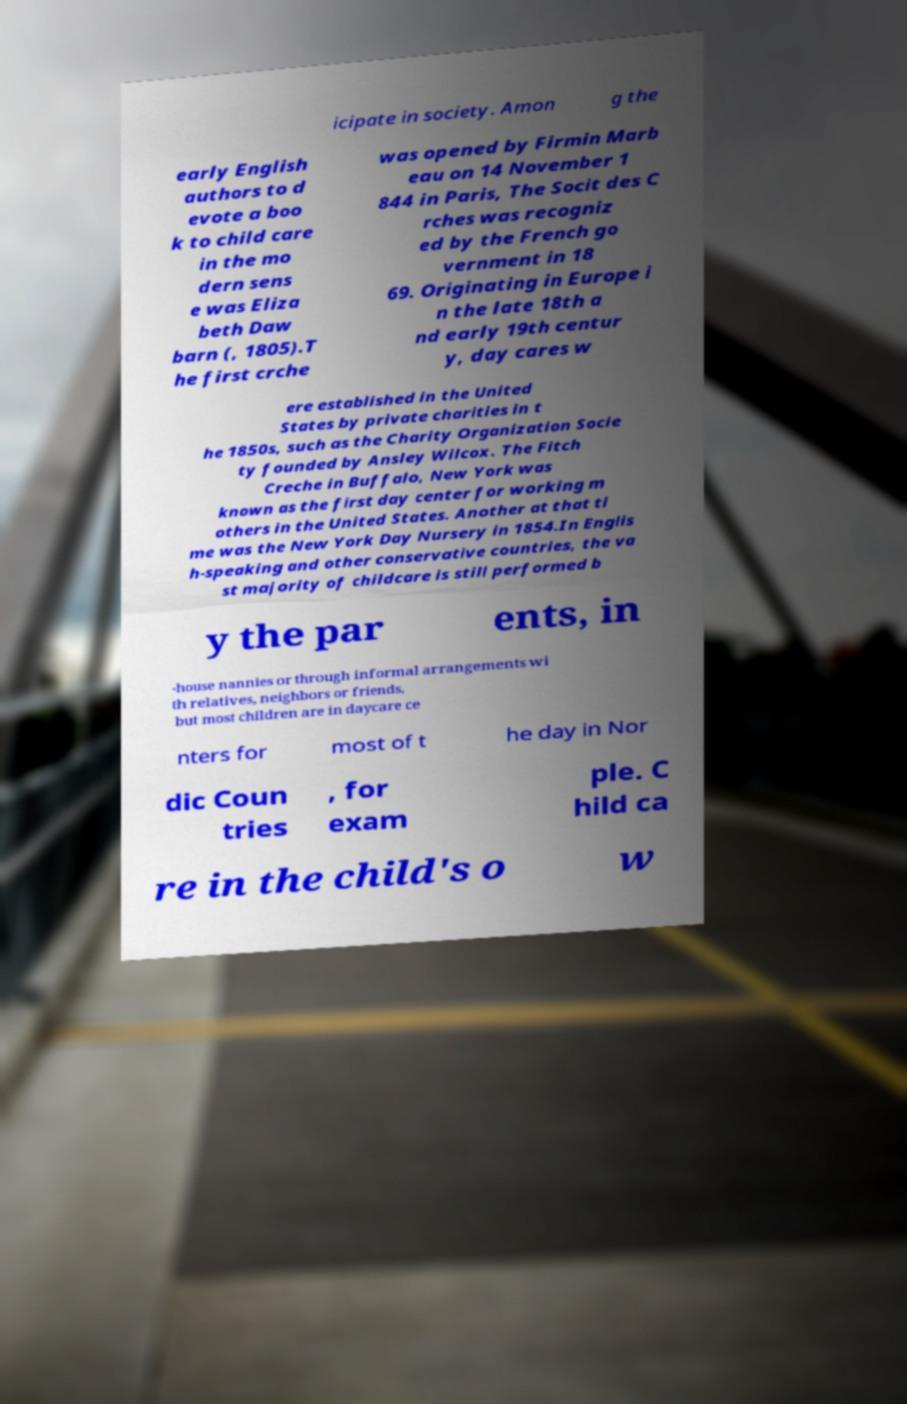What messages or text are displayed in this image? I need them in a readable, typed format. icipate in society. Amon g the early English authors to d evote a boo k to child care in the mo dern sens e was Eliza beth Daw barn (, 1805).T he first crche was opened by Firmin Marb eau on 14 November 1 844 in Paris, The Socit des C rches was recogniz ed by the French go vernment in 18 69. Originating in Europe i n the late 18th a nd early 19th centur y, day cares w ere established in the United States by private charities in t he 1850s, such as the Charity Organization Socie ty founded by Ansley Wilcox. The Fitch Creche in Buffalo, New York was known as the first day center for working m others in the United States. Another at that ti me was the New York Day Nursery in 1854.In Englis h-speaking and other conservative countries, the va st majority of childcare is still performed b y the par ents, in -house nannies or through informal arrangements wi th relatives, neighbors or friends, but most children are in daycare ce nters for most of t he day in Nor dic Coun tries , for exam ple. C hild ca re in the child's o w 